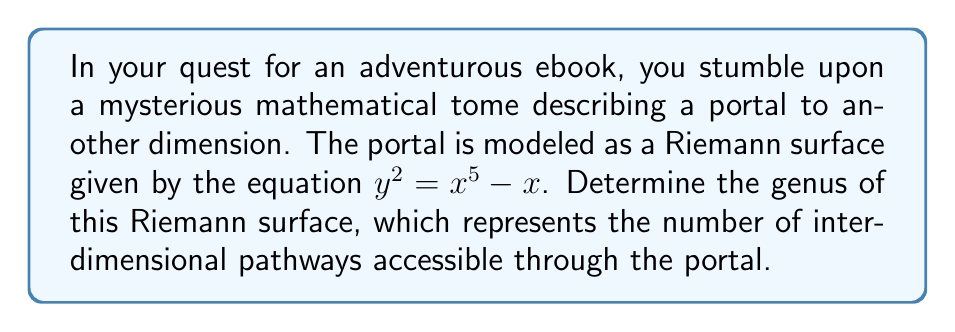Can you answer this question? To find the genus of the Riemann surface, we'll follow these steps:

1) The given equation $y^2 = x^5 - x$ represents a hyperelliptic curve.

2) For a hyperelliptic curve of the form $y^2 = f(x)$, where $f(x)$ is a polynomial, the genus $g$ is related to the degree $d$ of $f(x)$ by the formula:

   $$g = \left\lfloor\frac{d-1}{2}\right\rfloor$$

   where $\lfloor \cdot \rfloor$ denotes the floor function.

3) In our case, $f(x) = x^5 - x$, which is a polynomial of degree 5.

4) Substituting $d = 5$ into the formula:

   $$g = \left\lfloor\frac{5-1}{2}\right\rfloor = \left\lfloor\frac{4}{2}\right\rfloor = 2$$

5) Therefore, the genus of the Riemann surface is 2.

This means the portal has two distinct interdimensional pathways or "handles" connecting different regions of the surface.
Answer: 2 